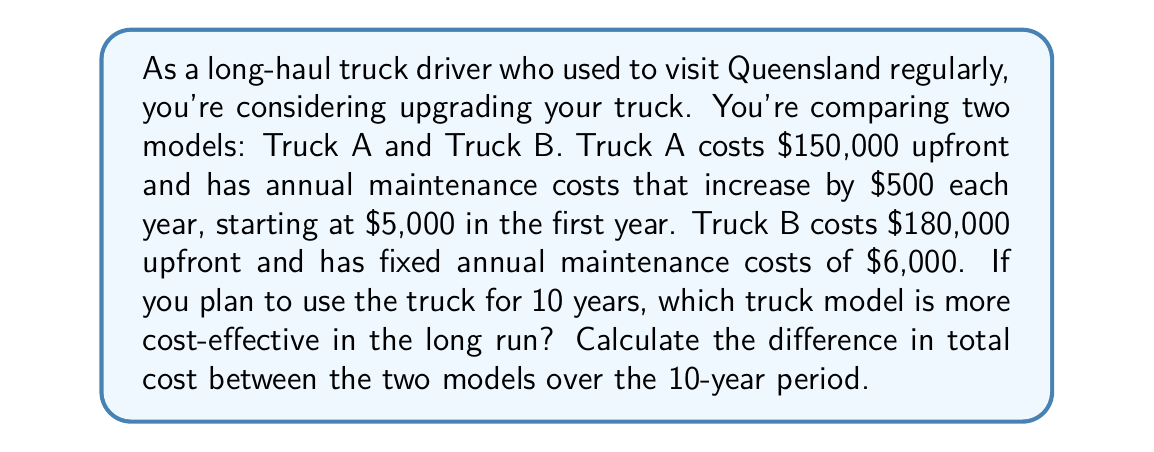Show me your answer to this math problem. Let's break this down step-by-step:

1) For Truck A:
   - Upfront cost: $150,000
   - Maintenance costs form an arithmetic sequence with:
     First term $a_1 = 5000$
     Common difference $d = 500$
   
   The sum of an arithmetic sequence is given by:
   $$S_n = \frac{n}{2}(a_1 + a_n)$$
   where $a_n = a_1 + (n-1)d$

   For 10 years:
   $a_{10} = 5000 + (10-1)500 = 9500$

   Total maintenance cost:
   $$S_{10} = \frac{10}{2}(5000 + 9500) = 72,500$$

   Total cost for Truck A = $150,000 + $72,500 = $222,500

2) For Truck B:
   - Upfront cost: $180,000
   - Annual maintenance cost: $6,000
   
   Total maintenance cost over 10 years:
   $6,000 * 10 = $60,000

   Total cost for Truck B = $180,000 + $60,000 = $240,000

3) Difference in total cost:
   $240,000 - $222,500 = $17,500
Answer: Truck A is more cost-effective in the long run. The difference in total cost over the 10-year period is $17,500, with Truck A being $17,500 cheaper than Truck B. 